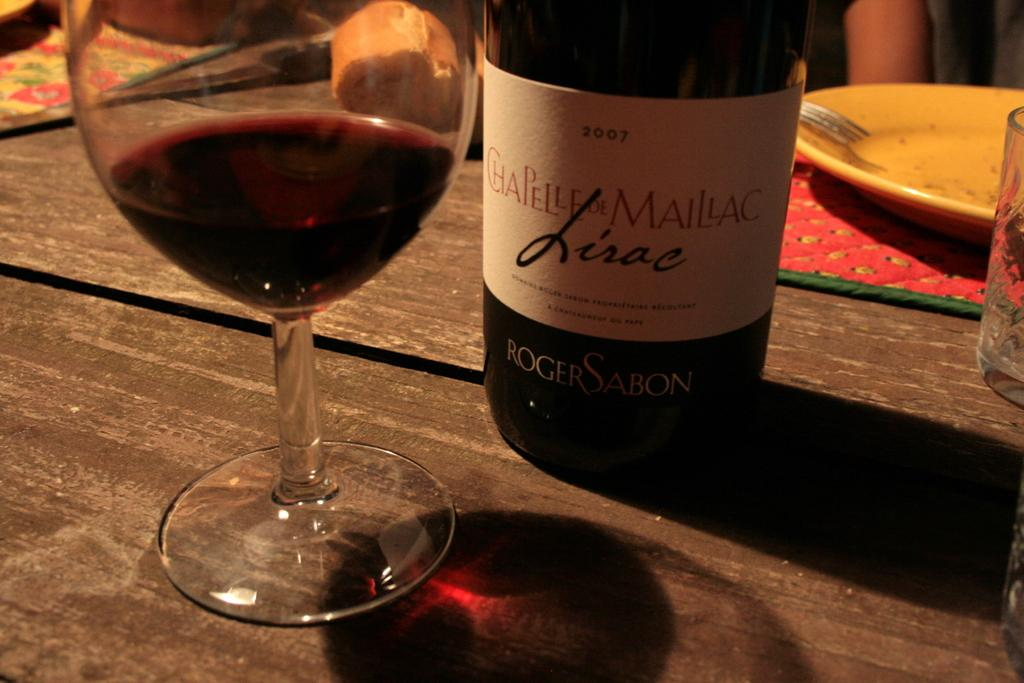<image>
Summarize the visual content of the image. A half empty glass of red wine by Chapelle De Maillac 